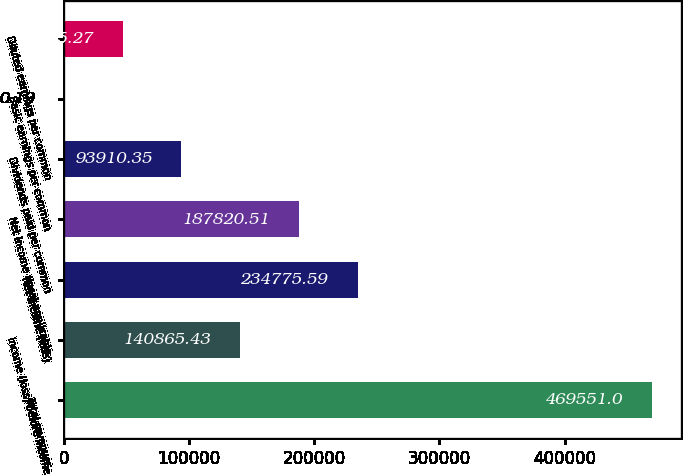<chart> <loc_0><loc_0><loc_500><loc_500><bar_chart><fcel>Total revenues<fcel>Income (loss) before income<fcel>Net income (loss)<fcel>Net income (loss) applicable<fcel>Dividends paid per common<fcel>Basic earnings per common<fcel>Diluted earnings per common<nl><fcel>469551<fcel>140865<fcel>234776<fcel>187821<fcel>93910.4<fcel>0.19<fcel>46955.3<nl></chart> 